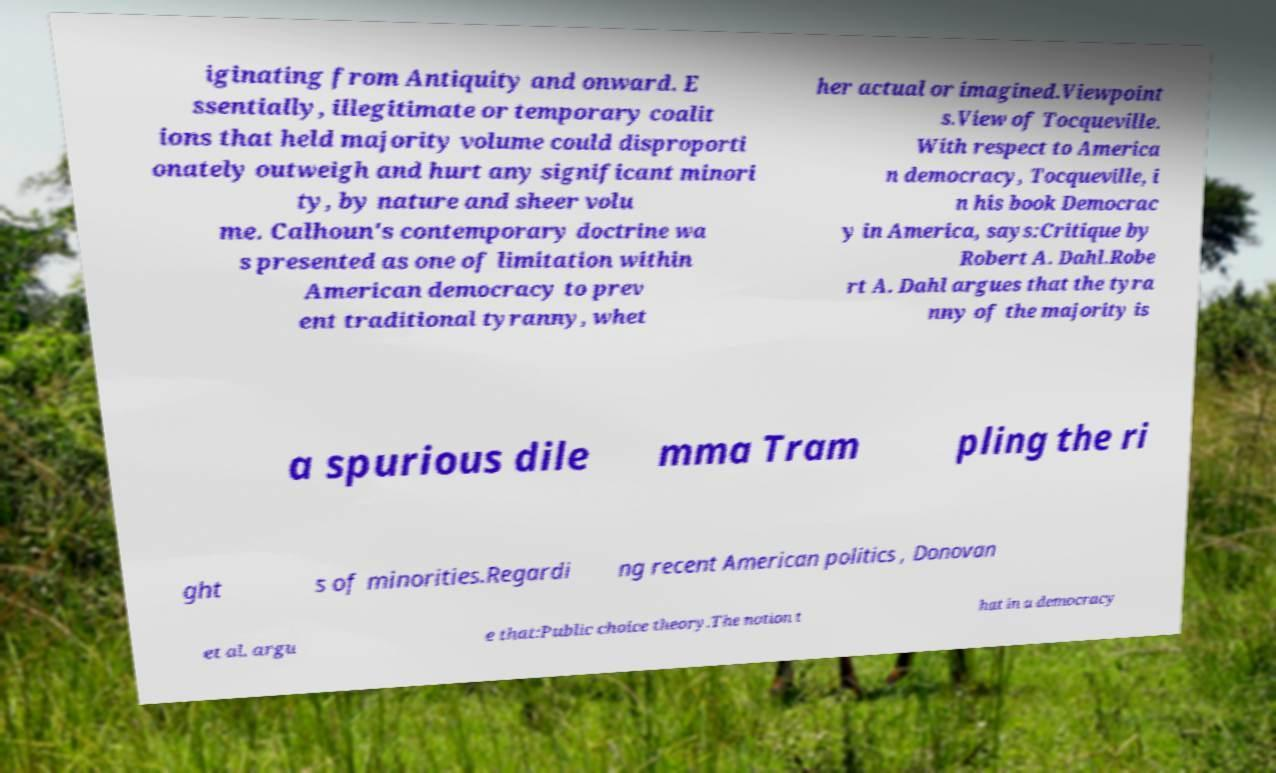Could you assist in decoding the text presented in this image and type it out clearly? iginating from Antiquity and onward. E ssentially, illegitimate or temporary coalit ions that held majority volume could disproporti onately outweigh and hurt any significant minori ty, by nature and sheer volu me. Calhoun's contemporary doctrine wa s presented as one of limitation within American democracy to prev ent traditional tyranny, whet her actual or imagined.Viewpoint s.View of Tocqueville. With respect to America n democracy, Tocqueville, i n his book Democrac y in America, says:Critique by Robert A. Dahl.Robe rt A. Dahl argues that the tyra nny of the majority is a spurious dile mma Tram pling the ri ght s of minorities.Regardi ng recent American politics , Donovan et al. argu e that:Public choice theory.The notion t hat in a democracy 